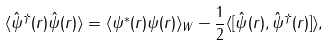Convert formula to latex. <formula><loc_0><loc_0><loc_500><loc_500>\langle \hat { \psi } ^ { \dagger } ( r ) \hat { \psi } ( r ) \rangle = \langle { \psi } ^ { * } ( r ) { \psi } ( r ) \rangle _ { W } - \frac { 1 } { 2 } \langle [ \hat { \psi } ( r ) , \hat { \psi } ^ { \dagger } ( r ) ] \rangle ,</formula> 